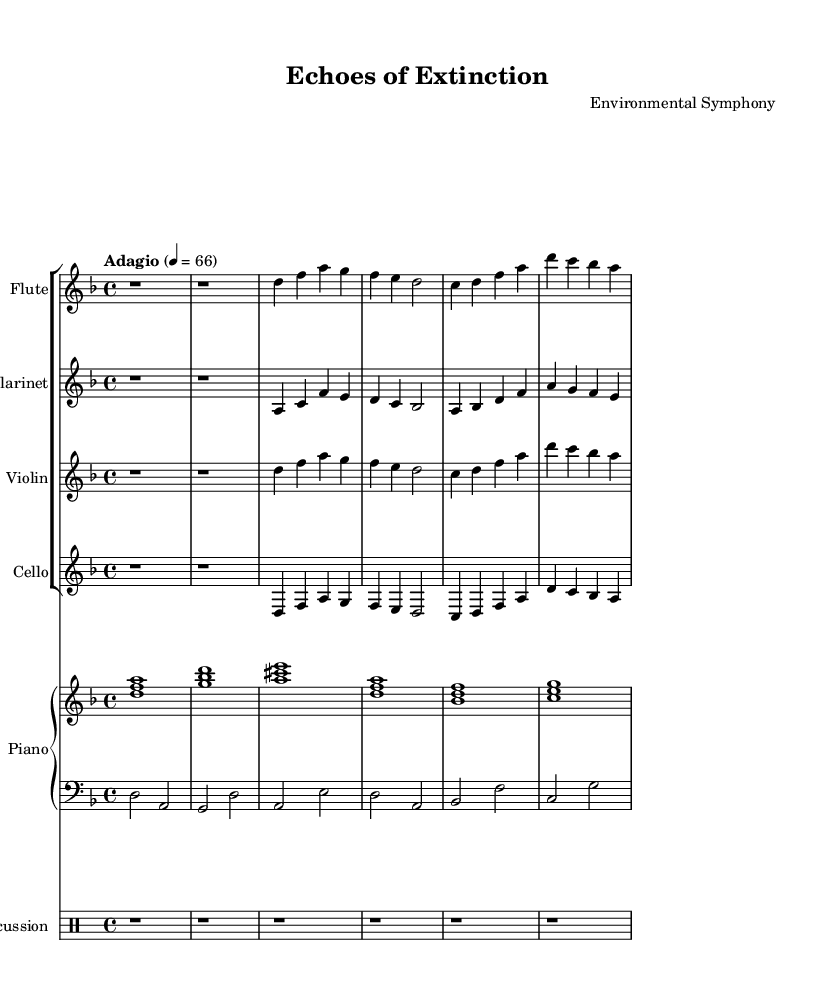What is the key signature of this music? The key signature is D minor, which has one flat, represented at the beginning of the staff.
Answer: D minor What is the time signature of this piece? The time signature is indicated as 4/4, meaning four beats per measure, with a quarter note receiving one beat.
Answer: 4/4 What is the tempo marking for this composition? The tempo marking is "Adagio," which indicates a slow tempo, typically considered slower than andante.
Answer: Adagio Which instruments are featured in this piece? The piece features a flute, clarinet, violin, cello, and piano with percussion. This can be seen at the start of each staff indicating the instrument names.
Answer: Flute, Clarinet, Violin, Cello, Piano, Percussion How many measures are there in the flute part? The flute part is composed of six measures, counted by the vertical lines separating each measure in the staff.
Answer: 6 What is unique about this piece concerning contemporary classical music? This piece incorporates sounds of endangered species, which is a characteristic of contemporary classical music's environmental themes.
Answer: Environmental themes 